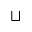Convert formula to latex. <formula><loc_0><loc_0><loc_500><loc_500>\sqcup</formula> 